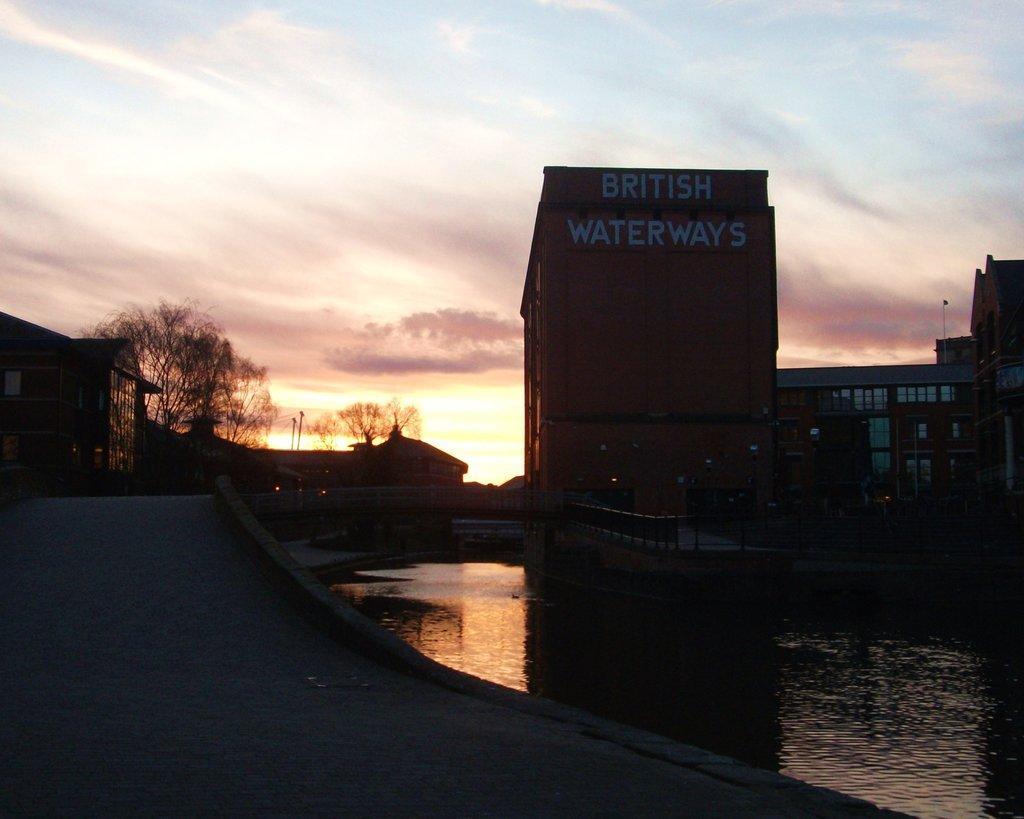How would you summarize this image in a sentence or two? In this image I can see water, bridge, trees, houses, buildings, fence, board and the sky. This image is taken may be in the evening. 